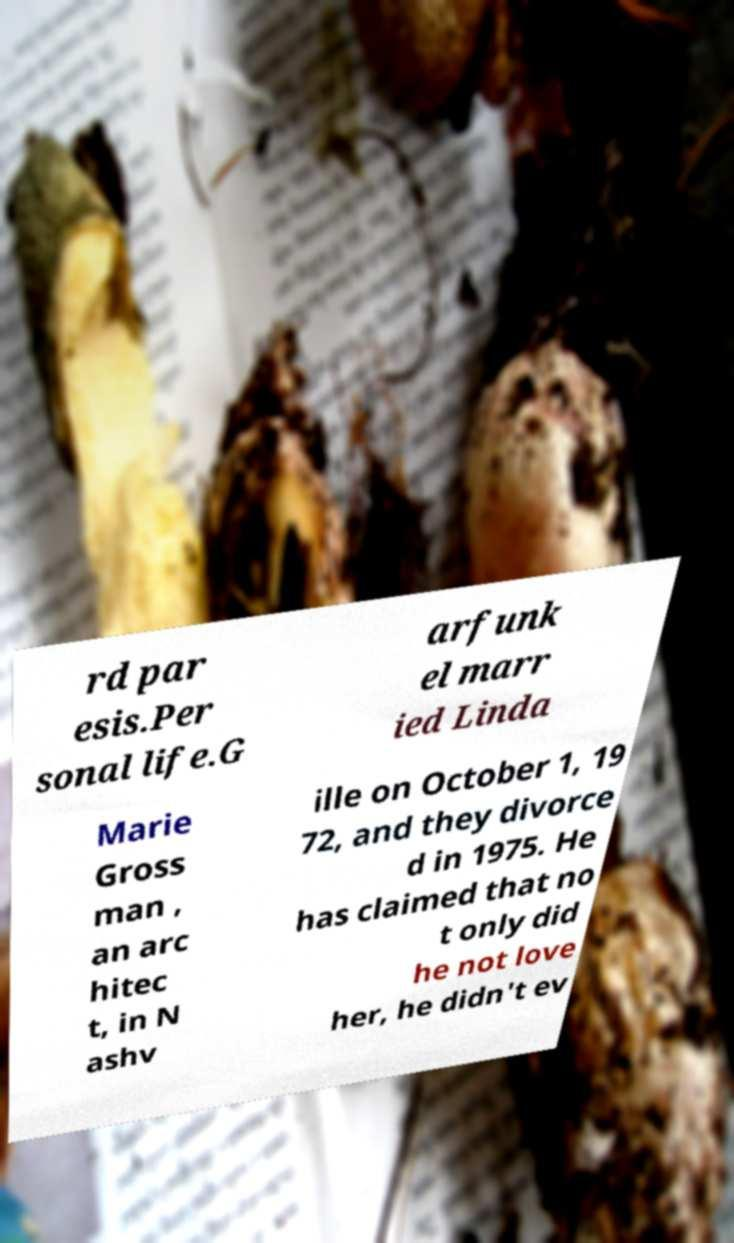I need the written content from this picture converted into text. Can you do that? rd par esis.Per sonal life.G arfunk el marr ied Linda Marie Gross man , an arc hitec t, in N ashv ille on October 1, 19 72, and they divorce d in 1975. He has claimed that no t only did he not love her, he didn't ev 